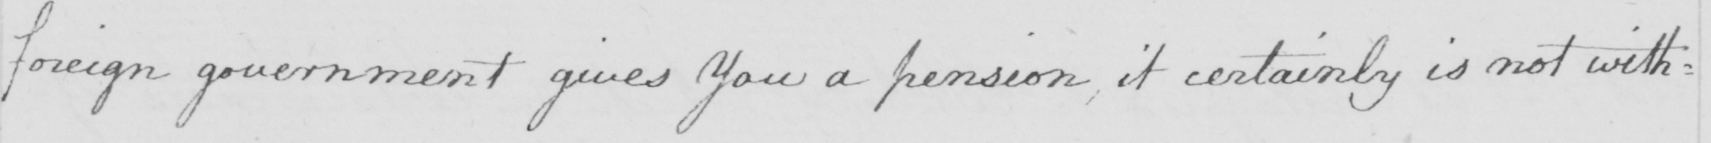Please provide the text content of this handwritten line. foreign government gives you a pension , it certainly is not with= 